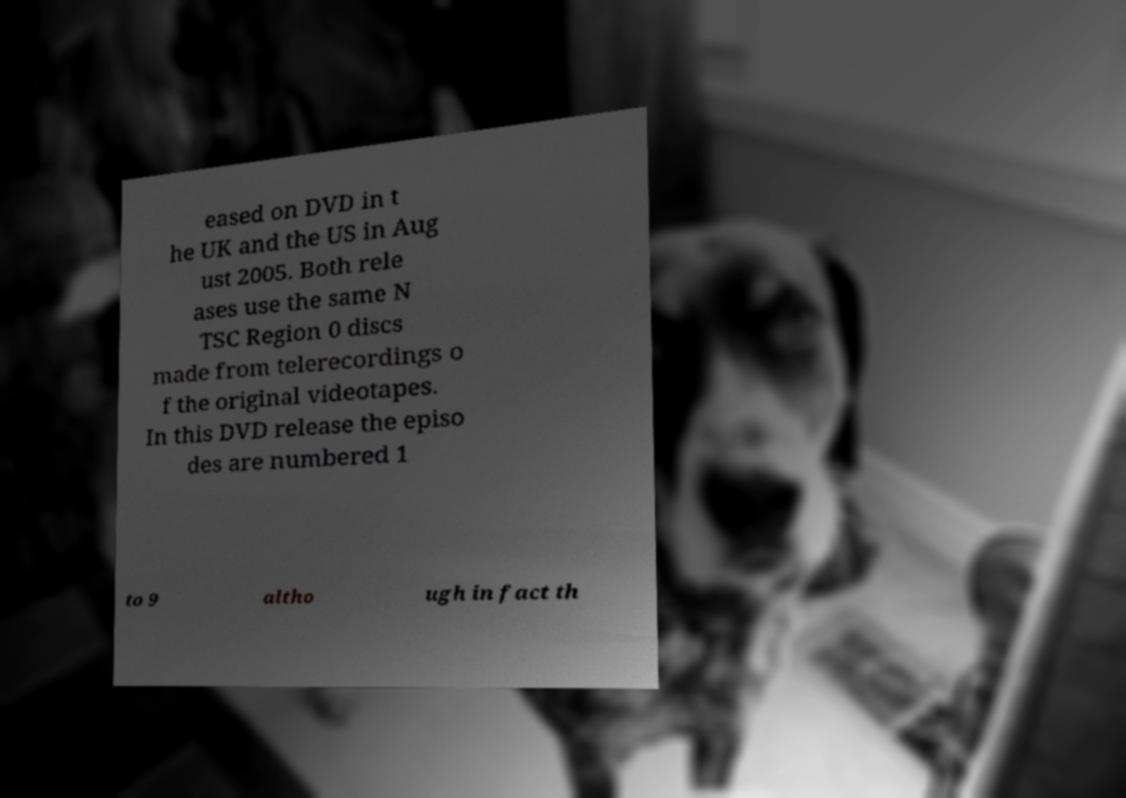Could you assist in decoding the text presented in this image and type it out clearly? eased on DVD in t he UK and the US in Aug ust 2005. Both rele ases use the same N TSC Region 0 discs made from telerecordings o f the original videotapes. In this DVD release the episo des are numbered 1 to 9 altho ugh in fact th 